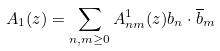Convert formula to latex. <formula><loc_0><loc_0><loc_500><loc_500>A _ { 1 } ( z ) = \sum _ { n , m \geq 0 } A _ { n m } ^ { 1 } ( z ) b _ { n } \cdot \overline { b } _ { m }</formula> 